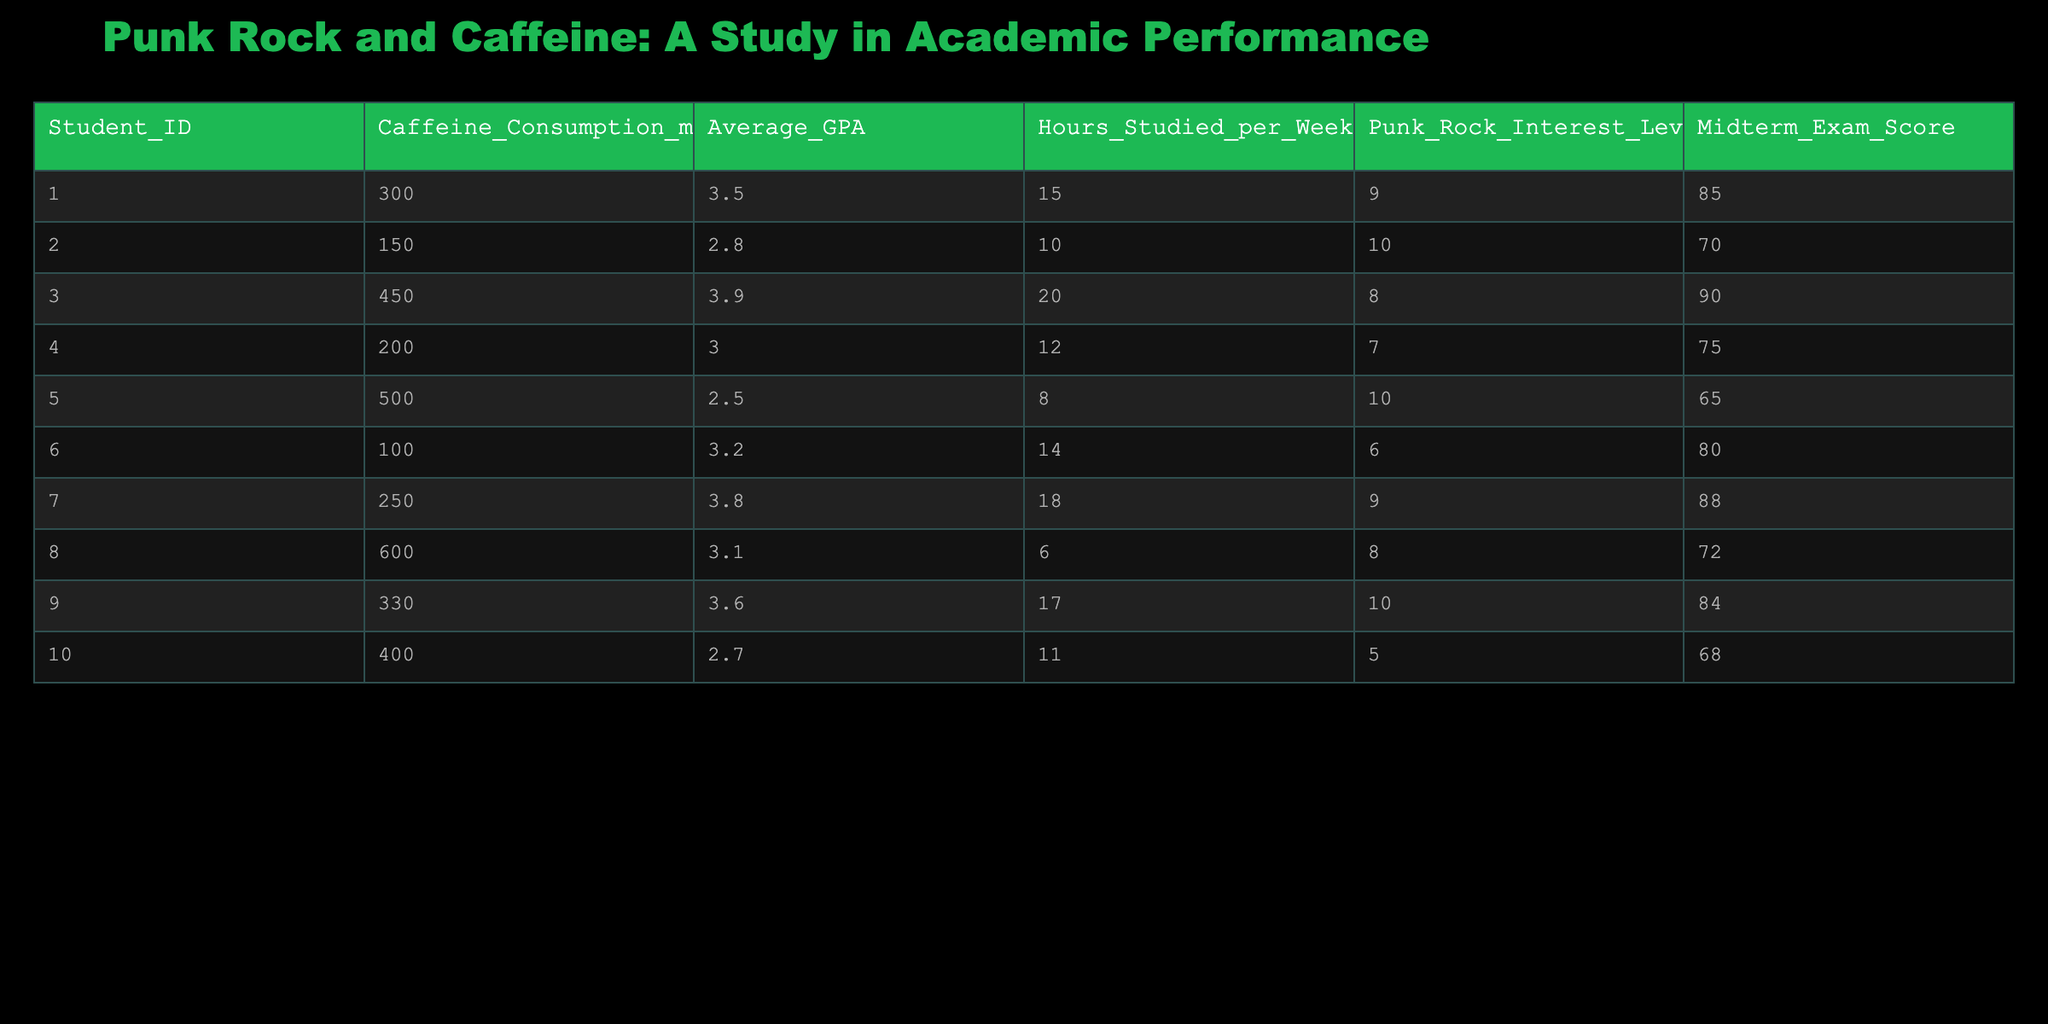What is the highest caffeine consumption recorded in the table? Looking through the Caffeine Consumption column, the value 600 mg appears as the highest.
Answer: 600 mg Which student has the lowest average GPA? By checking the Average GPA column, the lowest value is 2.5, which corresponds to Student ID 005.
Answer: 2.5 What is the average midterm exam score for students who study 15 hours or more per week? Students who study 15 hours or more per week are ID 001, 003, 007, and 009 with scores of 85, 90, 88, and 84 respectively. Adding these gives 347. There are 4 students, so the average is 347/4 = 86.75.
Answer: 86.75 Is there any student with a caffeine consumption of exactly 300 mg? Checking the Caffeine Consumption column reveals that Student ID 001 has a caffeine consumption of 300 mg.
Answer: Yes What is the total GPA of students with a punk rock interest level of 10? The students with a punk rock interest level of 10 are ID 002 and ID 005, with GPAs of 2.8 and 2.5 respectively. Summing these gives 2.8 + 2.5 = 5.3.
Answer: 5.3 